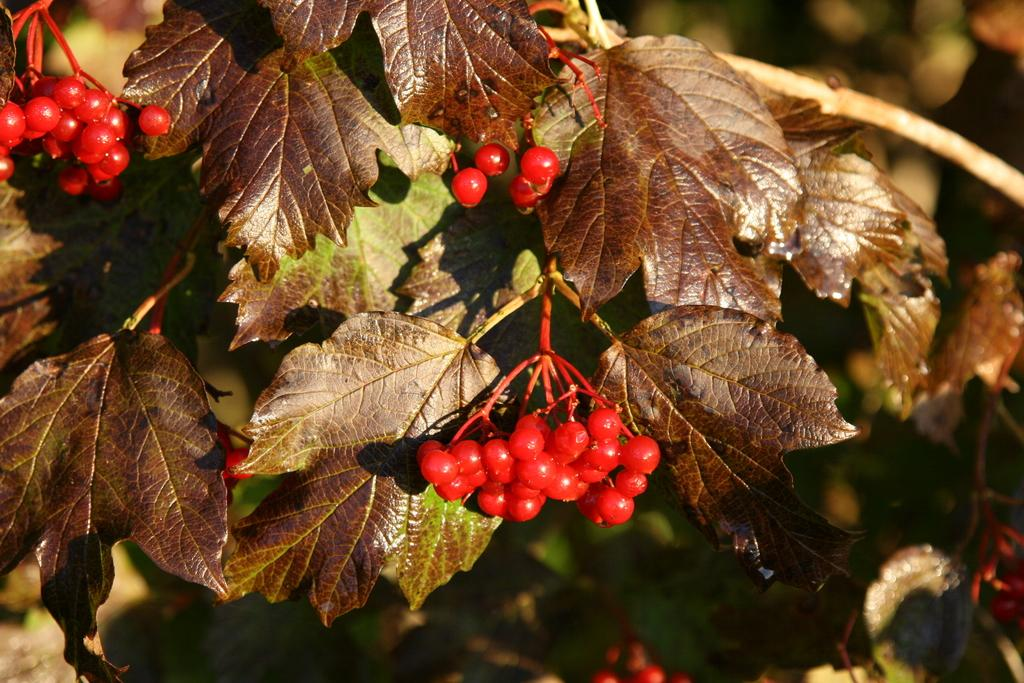What type of fruit is present in the image? There are cherries in the image. What else can be seen in the image besides the cherries? There are leaves in the image. How does the bone move around in the image? There is no bone present in the image. 